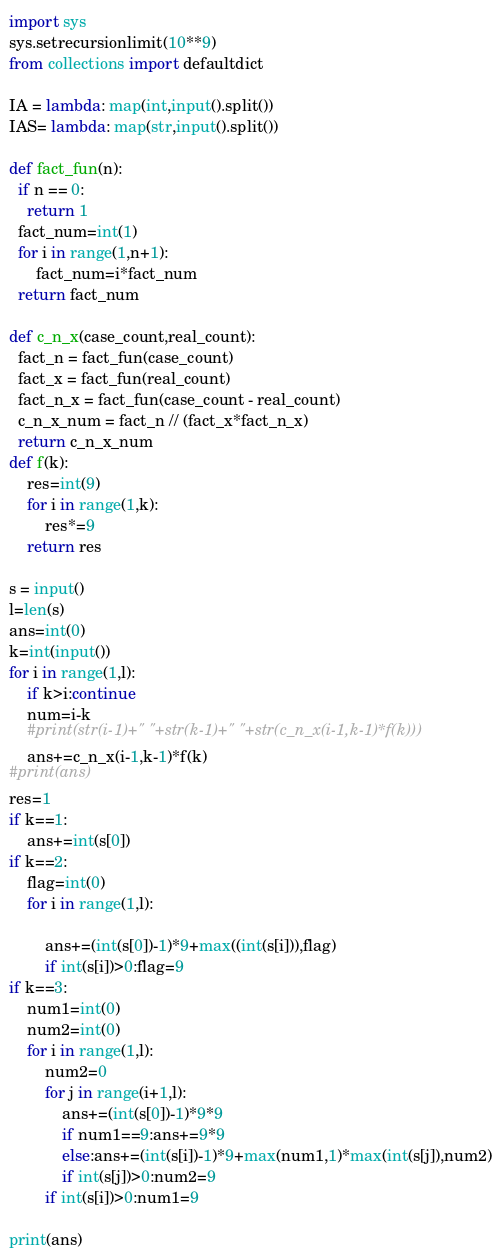Convert code to text. <code><loc_0><loc_0><loc_500><loc_500><_Python_>import sys
sys.setrecursionlimit(10**9)
from collections import defaultdict

IA = lambda: map(int,input().split())
IAS= lambda: map(str,input().split())

def fact_fun(n):
  if n == 0:
    return 1
  fact_num=int(1) 
  for i in range(1,n+1):
      fact_num=i*fact_num
  return fact_num

def c_n_x(case_count,real_count):
  fact_n = fact_fun(case_count)
  fact_x = fact_fun(real_count)
  fact_n_x = fact_fun(case_count - real_count)
  c_n_x_num = fact_n // (fact_x*fact_n_x)
  return c_n_x_num
def f(k):
    res=int(9)
    for i in range(1,k):
        res*=9
    return res

s = input()
l=len(s)
ans=int(0)
k=int(input())
for i in range(1,l):
    if k>i:continue
    num=i-k
    #print(str(i-1)+" "+str(k-1)+" "+str(c_n_x(i-1,k-1)*f(k)))
    ans+=c_n_x(i-1,k-1)*f(k)
#print(ans)
res=1
if k==1:
    ans+=int(s[0])
if k==2:
    flag=int(0)
    for i in range(1,l):
        
        ans+=(int(s[0])-1)*9+max((int(s[i])),flag)
        if int(s[i])>0:flag=9
if k==3:
    num1=int(0)
    num2=int(0)
    for i in range(1,l):
        num2=0
        for j in range(i+1,l):
            ans+=(int(s[0])-1)*9*9
            if num1==9:ans+=9*9
            else:ans+=(int(s[i])-1)*9+max(num1,1)*max(int(s[j]),num2)
            if int(s[j])>0:num2=9
        if int(s[i])>0:num1=9
       
print(ans)


</code> 